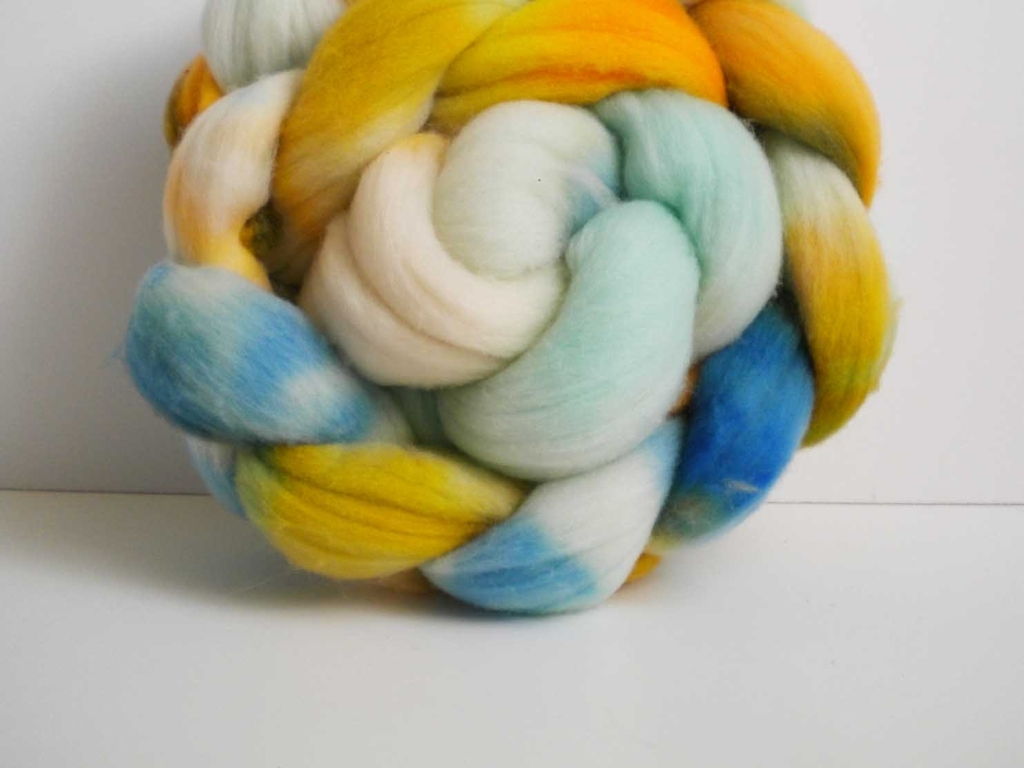Can you describe what this object is and what it's typically used for? The image displays a bundle of wool roving, which is unspun fibers. It's often used for various fiber arts such as felting, spinning into yarn, or even dye tests for creating new colorways. 